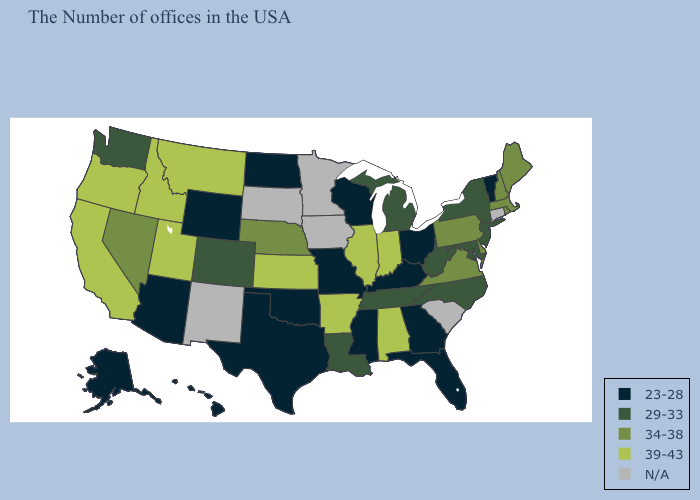Does the first symbol in the legend represent the smallest category?
Short answer required. Yes. Among the states that border Kentucky , does Ohio have the lowest value?
Give a very brief answer. Yes. What is the lowest value in states that border New Mexico?
Quick response, please. 23-28. Does New Hampshire have the lowest value in the Northeast?
Short answer required. No. Name the states that have a value in the range N/A?
Answer briefly. Connecticut, South Carolina, Minnesota, Iowa, South Dakota, New Mexico. Name the states that have a value in the range N/A?
Keep it brief. Connecticut, South Carolina, Minnesota, Iowa, South Dakota, New Mexico. Which states have the lowest value in the USA?
Concise answer only. Vermont, Ohio, Florida, Georgia, Kentucky, Wisconsin, Mississippi, Missouri, Oklahoma, Texas, North Dakota, Wyoming, Arizona, Alaska, Hawaii. Does Colorado have the lowest value in the USA?
Give a very brief answer. No. Does Maine have the highest value in the USA?
Give a very brief answer. No. Name the states that have a value in the range 23-28?
Keep it brief. Vermont, Ohio, Florida, Georgia, Kentucky, Wisconsin, Mississippi, Missouri, Oklahoma, Texas, North Dakota, Wyoming, Arizona, Alaska, Hawaii. Does the map have missing data?
Keep it brief. Yes. Among the states that border New York , does Pennsylvania have the lowest value?
Keep it brief. No. What is the highest value in the USA?
Give a very brief answer. 39-43. What is the highest value in the USA?
Keep it brief. 39-43. 